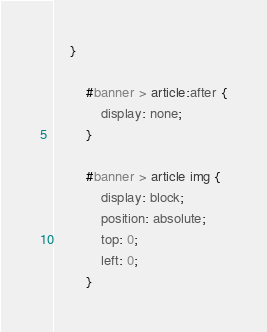Convert code to text. <code><loc_0><loc_0><loc_500><loc_500><_CSS_>	}

		#banner > article:after {
			display: none;
		}

		#banner > article img {
			display: block;
			position: absolute;
			top: 0;
			left: 0;
		}</code> 